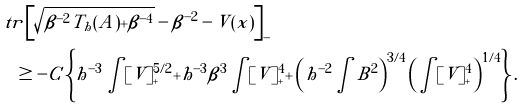Convert formula to latex. <formula><loc_0><loc_0><loc_500><loc_500>& \ t r \left [ \sqrt { \beta ^ { - 2 } T _ { h } ( A ) + \beta ^ { - 4 } } - \beta ^ { - 2 } - V ( x ) \right ] _ { - } \\ & \quad \geq - C \left \{ h ^ { - 3 } \int [ V ] _ { + } ^ { 5 / 2 } + h ^ { - 3 } \beta ^ { 3 } \int [ V ] _ { + } ^ { 4 } + \left ( h ^ { - 2 } \int B ^ { 2 } \right ) ^ { 3 / 4 } \left ( \int [ V ] _ { + } ^ { 4 } \right ) ^ { 1 / 4 } \right \} .</formula> 